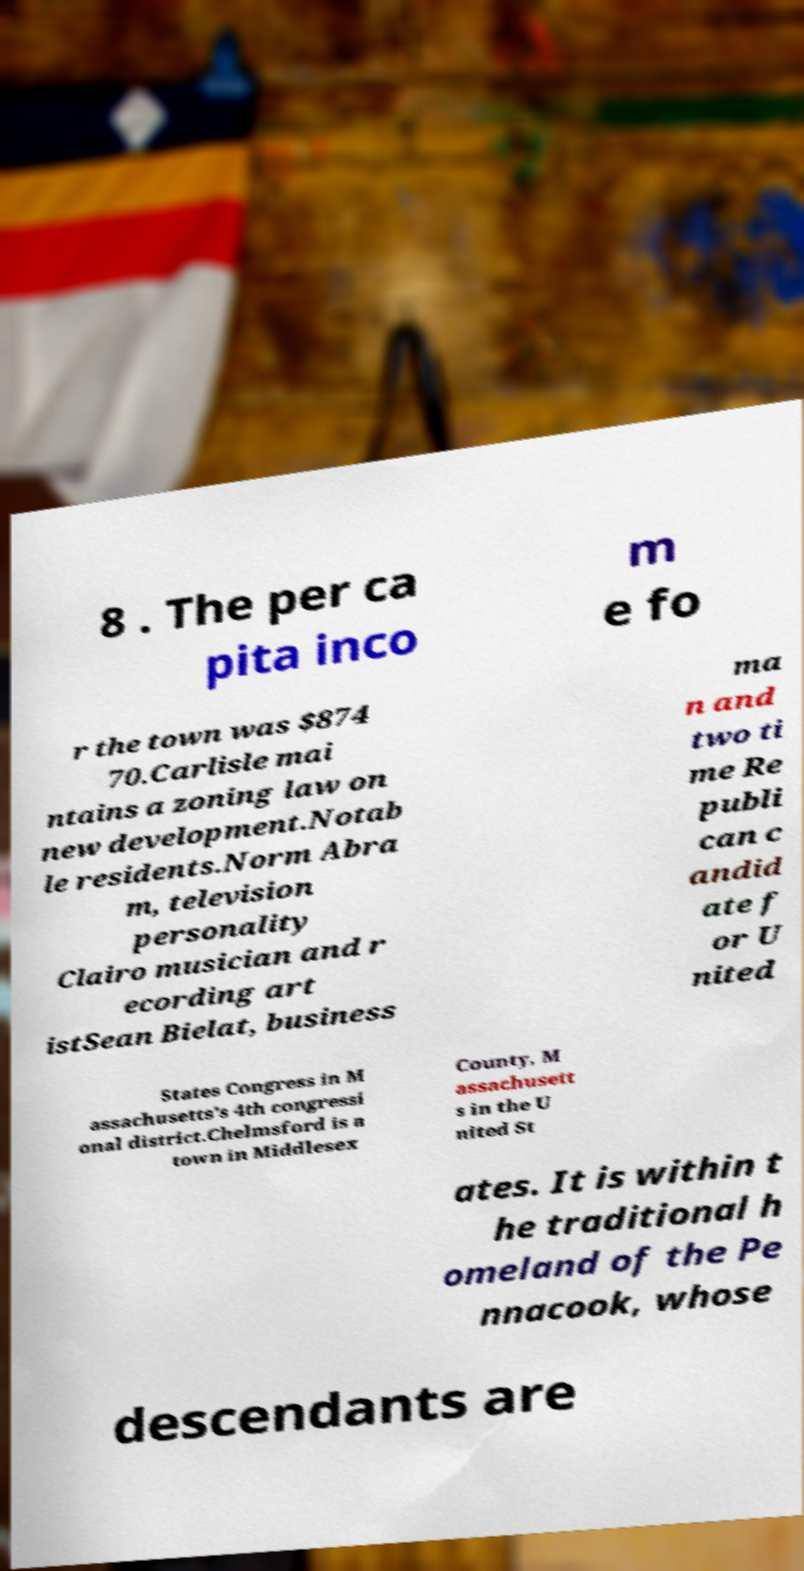Please read and relay the text visible in this image. What does it say? 8 . The per ca pita inco m e fo r the town was $874 70.Carlisle mai ntains a zoning law on new development.Notab le residents.Norm Abra m, television personality Clairo musician and r ecording art istSean Bielat, business ma n and two ti me Re publi can c andid ate f or U nited States Congress in M assachusetts's 4th congressi onal district.Chelmsford is a town in Middlesex County, M assachusett s in the U nited St ates. It is within t he traditional h omeland of the Pe nnacook, whose descendants are 